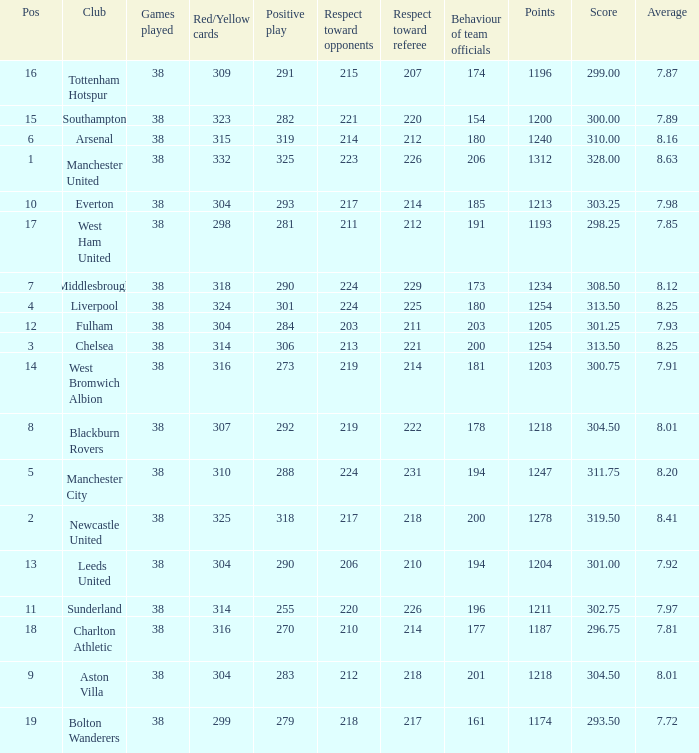Name the most pos for west bromwich albion club 14.0. 